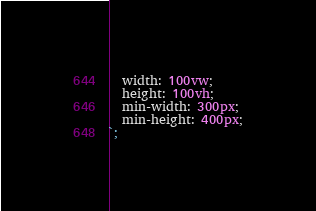<code> <loc_0><loc_0><loc_500><loc_500><_TypeScript_>  width: 100vw;
  height: 100vh;
  min-width: 300px;
  min-height: 400px;
`;
</code> 